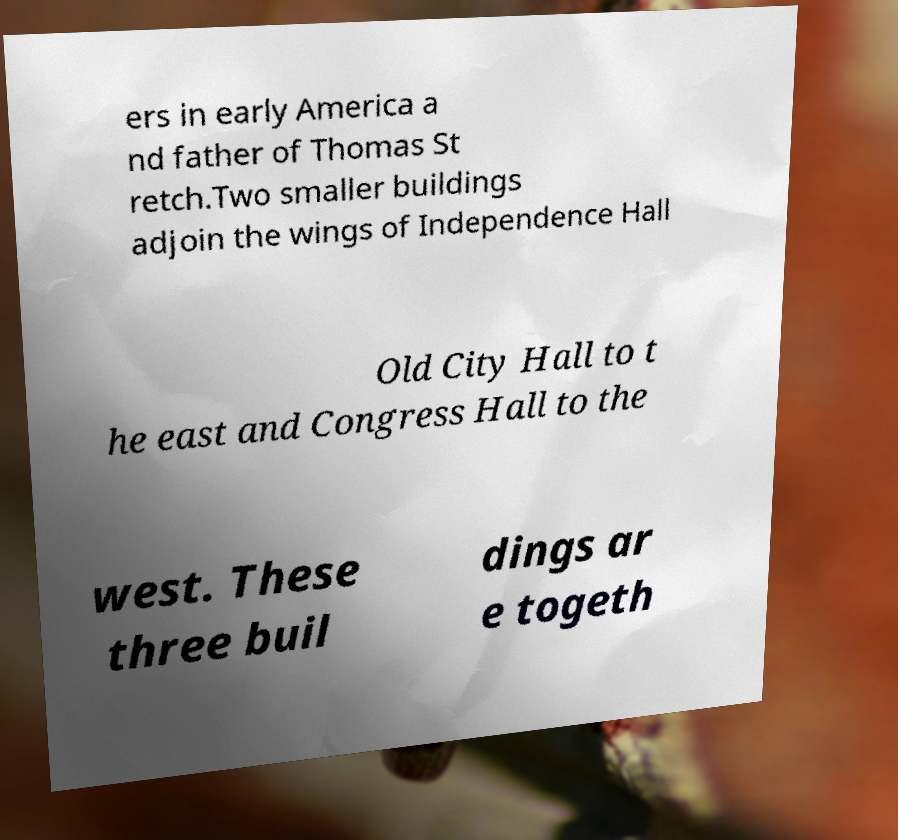There's text embedded in this image that I need extracted. Can you transcribe it verbatim? ers in early America a nd father of Thomas St retch.Two smaller buildings adjoin the wings of Independence Hall Old City Hall to t he east and Congress Hall to the west. These three buil dings ar e togeth 